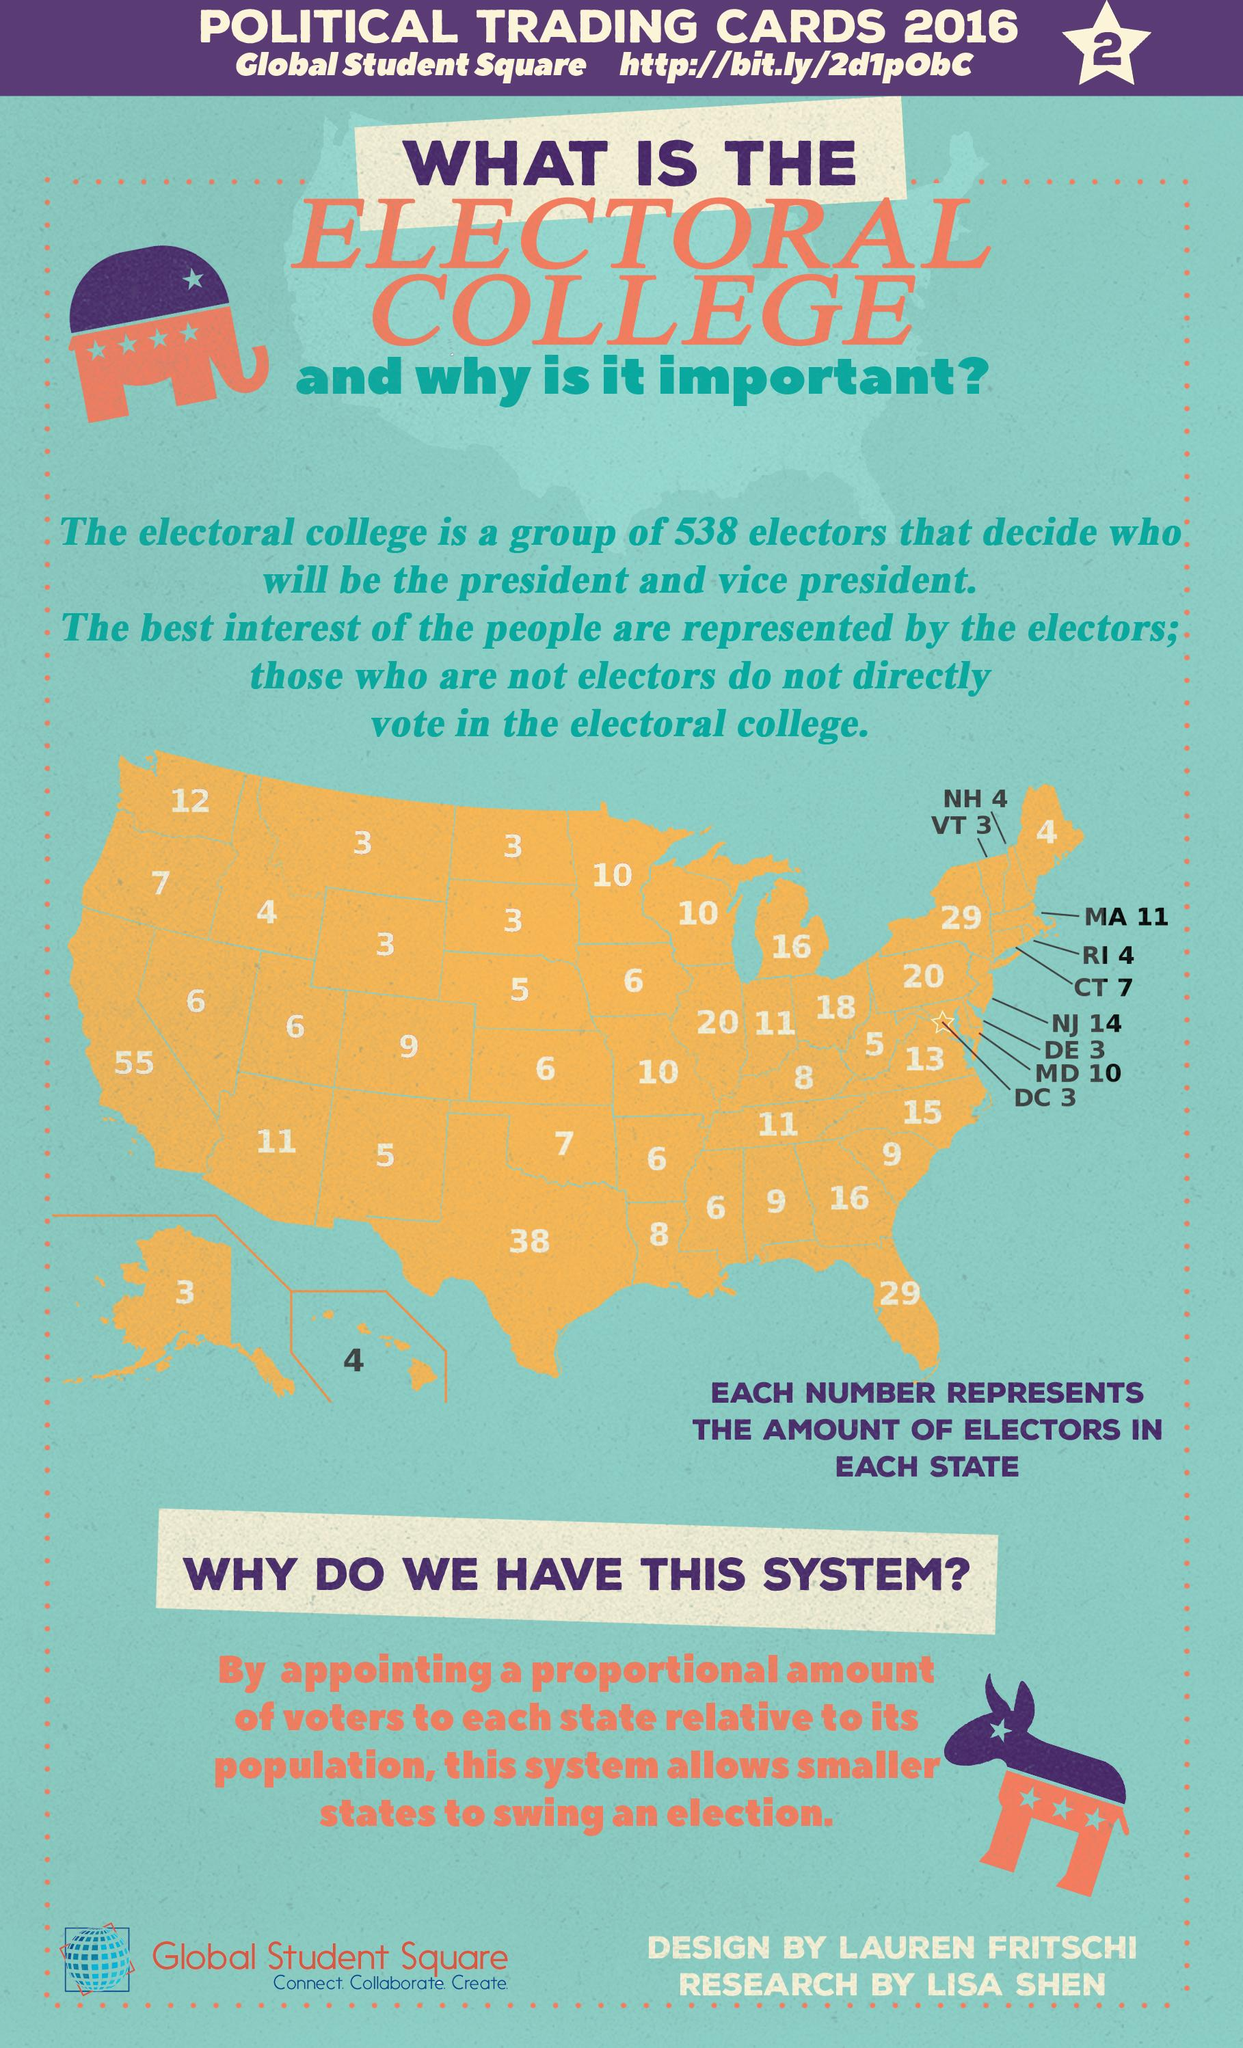Point out several critical features in this image. California has the most number of electors in the US electoral college. The total number of electors in the United States electoral college is 538 electors. Four electoral votes are allocated to Hawaii in the United States electoral college. The state of Florida is represented by 29 electors in the US electoral college. Alaska is represented by 3 electors in the US electoral college. 